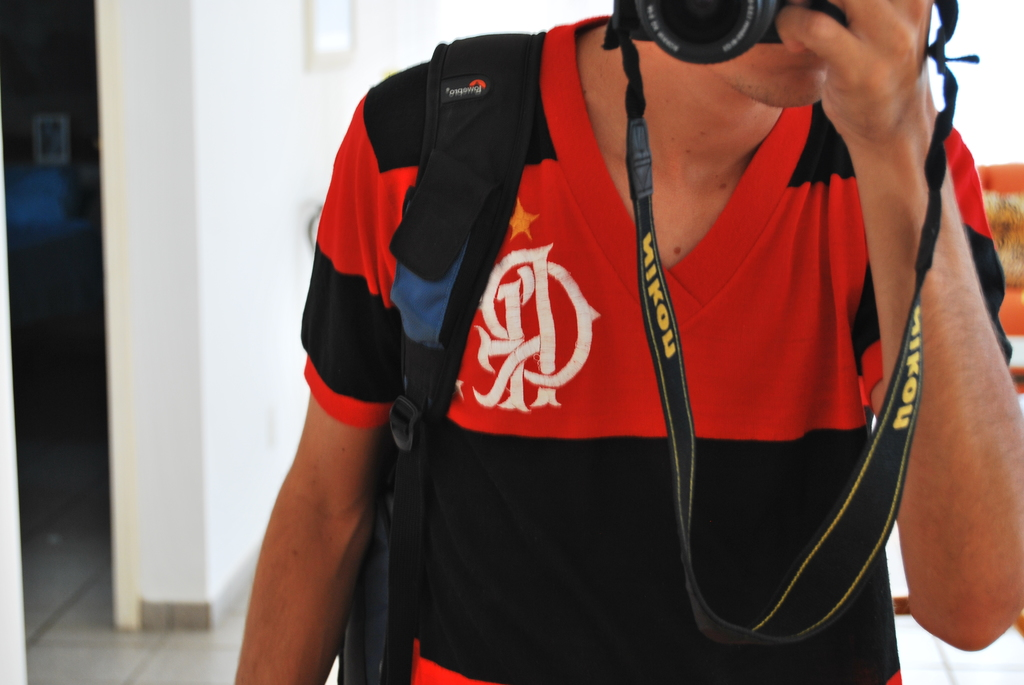Provide a one-sentence caption for the provided image. A photographer in a striking black and red jersey, emblazoned with a logo, captures a moment, his Nikon camera firmly secured by a strap. 